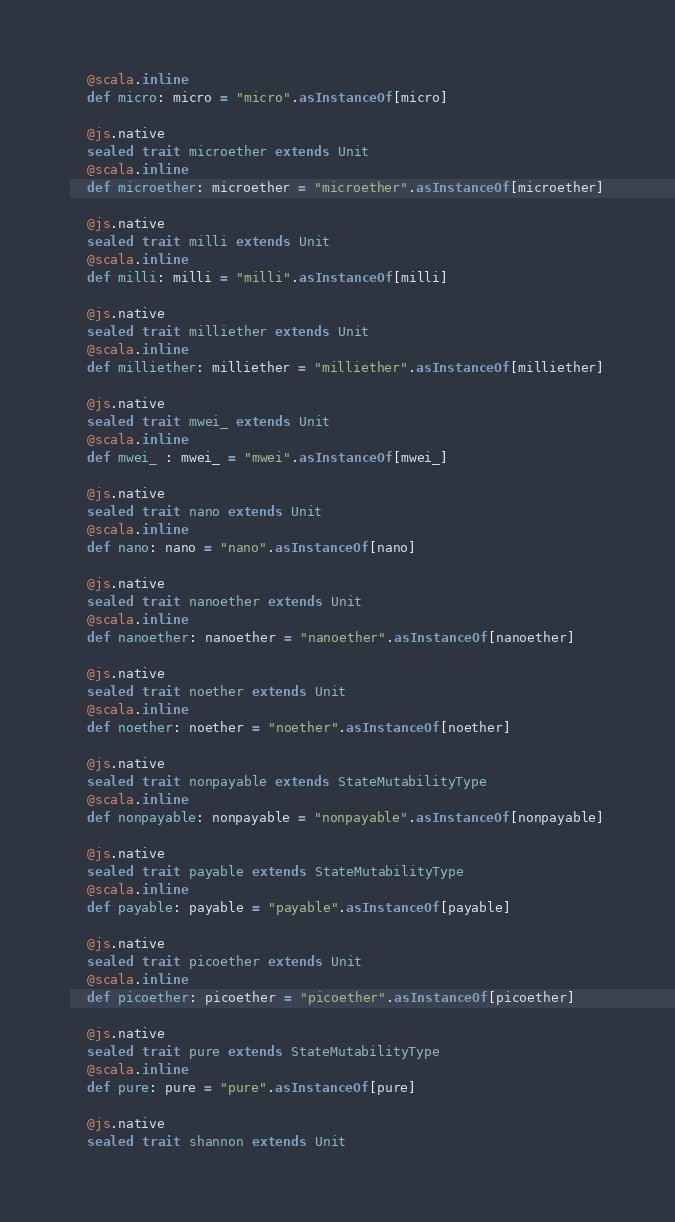Convert code to text. <code><loc_0><loc_0><loc_500><loc_500><_Scala_>  @scala.inline
  def micro: micro = "micro".asInstanceOf[micro]
  
  @js.native
  sealed trait microether extends Unit
  @scala.inline
  def microether: microether = "microether".asInstanceOf[microether]
  
  @js.native
  sealed trait milli extends Unit
  @scala.inline
  def milli: milli = "milli".asInstanceOf[milli]
  
  @js.native
  sealed trait milliether extends Unit
  @scala.inline
  def milliether: milliether = "milliether".asInstanceOf[milliether]
  
  @js.native
  sealed trait mwei_ extends Unit
  @scala.inline
  def mwei_ : mwei_ = "mwei".asInstanceOf[mwei_]
  
  @js.native
  sealed trait nano extends Unit
  @scala.inline
  def nano: nano = "nano".asInstanceOf[nano]
  
  @js.native
  sealed trait nanoether extends Unit
  @scala.inline
  def nanoether: nanoether = "nanoether".asInstanceOf[nanoether]
  
  @js.native
  sealed trait noether extends Unit
  @scala.inline
  def noether: noether = "noether".asInstanceOf[noether]
  
  @js.native
  sealed trait nonpayable extends StateMutabilityType
  @scala.inline
  def nonpayable: nonpayable = "nonpayable".asInstanceOf[nonpayable]
  
  @js.native
  sealed trait payable extends StateMutabilityType
  @scala.inline
  def payable: payable = "payable".asInstanceOf[payable]
  
  @js.native
  sealed trait picoether extends Unit
  @scala.inline
  def picoether: picoether = "picoether".asInstanceOf[picoether]
  
  @js.native
  sealed trait pure extends StateMutabilityType
  @scala.inline
  def pure: pure = "pure".asInstanceOf[pure]
  
  @js.native
  sealed trait shannon extends Unit</code> 